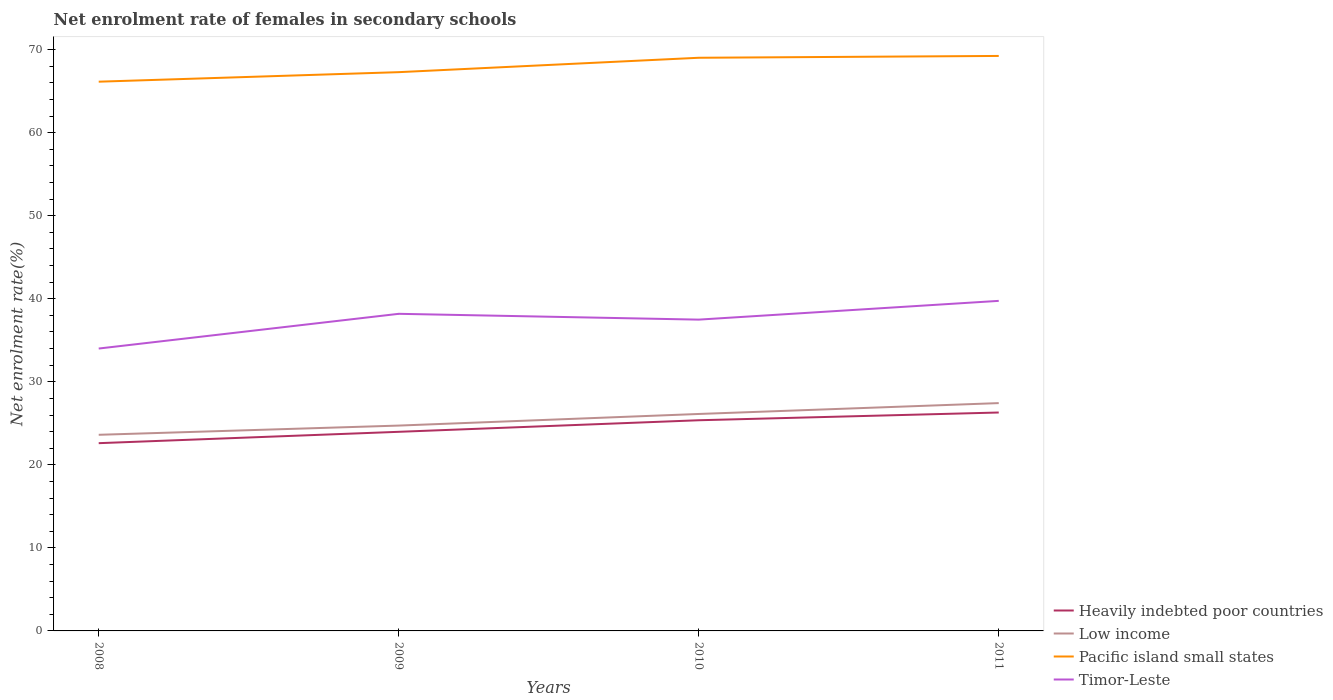Across all years, what is the maximum net enrolment rate of females in secondary schools in Timor-Leste?
Provide a short and direct response. 34.01. What is the total net enrolment rate of females in secondary schools in Heavily indebted poor countries in the graph?
Your answer should be very brief. -0.93. What is the difference between the highest and the second highest net enrolment rate of females in secondary schools in Low income?
Offer a very short reply. 3.82. What is the difference between the highest and the lowest net enrolment rate of females in secondary schools in Pacific island small states?
Your answer should be very brief. 2. Is the net enrolment rate of females in secondary schools in Heavily indebted poor countries strictly greater than the net enrolment rate of females in secondary schools in Pacific island small states over the years?
Your response must be concise. Yes. How many years are there in the graph?
Offer a terse response. 4. Are the values on the major ticks of Y-axis written in scientific E-notation?
Your response must be concise. No. Does the graph contain any zero values?
Give a very brief answer. No. Where does the legend appear in the graph?
Your answer should be compact. Bottom right. What is the title of the graph?
Give a very brief answer. Net enrolment rate of females in secondary schools. What is the label or title of the X-axis?
Your answer should be compact. Years. What is the label or title of the Y-axis?
Your answer should be compact. Net enrolment rate(%). What is the Net enrolment rate(%) of Heavily indebted poor countries in 2008?
Make the answer very short. 22.61. What is the Net enrolment rate(%) of Low income in 2008?
Keep it short and to the point. 23.62. What is the Net enrolment rate(%) in Pacific island small states in 2008?
Give a very brief answer. 66.15. What is the Net enrolment rate(%) in Timor-Leste in 2008?
Your answer should be very brief. 34.01. What is the Net enrolment rate(%) of Heavily indebted poor countries in 2009?
Ensure brevity in your answer.  23.98. What is the Net enrolment rate(%) in Low income in 2009?
Offer a very short reply. 24.73. What is the Net enrolment rate(%) of Pacific island small states in 2009?
Your response must be concise. 67.29. What is the Net enrolment rate(%) in Timor-Leste in 2009?
Give a very brief answer. 38.19. What is the Net enrolment rate(%) in Heavily indebted poor countries in 2010?
Make the answer very short. 25.37. What is the Net enrolment rate(%) of Low income in 2010?
Give a very brief answer. 26.13. What is the Net enrolment rate(%) in Pacific island small states in 2010?
Provide a short and direct response. 69.03. What is the Net enrolment rate(%) of Timor-Leste in 2010?
Offer a very short reply. 37.49. What is the Net enrolment rate(%) of Heavily indebted poor countries in 2011?
Ensure brevity in your answer.  26.3. What is the Net enrolment rate(%) of Low income in 2011?
Make the answer very short. 27.44. What is the Net enrolment rate(%) of Pacific island small states in 2011?
Make the answer very short. 69.25. What is the Net enrolment rate(%) in Timor-Leste in 2011?
Ensure brevity in your answer.  39.75. Across all years, what is the maximum Net enrolment rate(%) in Heavily indebted poor countries?
Your response must be concise. 26.3. Across all years, what is the maximum Net enrolment rate(%) in Low income?
Your answer should be compact. 27.44. Across all years, what is the maximum Net enrolment rate(%) in Pacific island small states?
Provide a short and direct response. 69.25. Across all years, what is the maximum Net enrolment rate(%) of Timor-Leste?
Ensure brevity in your answer.  39.75. Across all years, what is the minimum Net enrolment rate(%) of Heavily indebted poor countries?
Your answer should be very brief. 22.61. Across all years, what is the minimum Net enrolment rate(%) of Low income?
Provide a succinct answer. 23.62. Across all years, what is the minimum Net enrolment rate(%) of Pacific island small states?
Provide a short and direct response. 66.15. Across all years, what is the minimum Net enrolment rate(%) of Timor-Leste?
Ensure brevity in your answer.  34.01. What is the total Net enrolment rate(%) of Heavily indebted poor countries in the graph?
Keep it short and to the point. 98.27. What is the total Net enrolment rate(%) in Low income in the graph?
Ensure brevity in your answer.  101.92. What is the total Net enrolment rate(%) in Pacific island small states in the graph?
Keep it short and to the point. 271.71. What is the total Net enrolment rate(%) in Timor-Leste in the graph?
Ensure brevity in your answer.  149.44. What is the difference between the Net enrolment rate(%) in Heavily indebted poor countries in 2008 and that in 2009?
Your answer should be compact. -1.37. What is the difference between the Net enrolment rate(%) of Low income in 2008 and that in 2009?
Your answer should be compact. -1.11. What is the difference between the Net enrolment rate(%) in Pacific island small states in 2008 and that in 2009?
Make the answer very short. -1.15. What is the difference between the Net enrolment rate(%) in Timor-Leste in 2008 and that in 2009?
Offer a terse response. -4.18. What is the difference between the Net enrolment rate(%) in Heavily indebted poor countries in 2008 and that in 2010?
Keep it short and to the point. -2.76. What is the difference between the Net enrolment rate(%) of Low income in 2008 and that in 2010?
Ensure brevity in your answer.  -2.51. What is the difference between the Net enrolment rate(%) in Pacific island small states in 2008 and that in 2010?
Keep it short and to the point. -2.88. What is the difference between the Net enrolment rate(%) in Timor-Leste in 2008 and that in 2010?
Provide a succinct answer. -3.48. What is the difference between the Net enrolment rate(%) in Heavily indebted poor countries in 2008 and that in 2011?
Keep it short and to the point. -3.69. What is the difference between the Net enrolment rate(%) in Low income in 2008 and that in 2011?
Your response must be concise. -3.82. What is the difference between the Net enrolment rate(%) of Pacific island small states in 2008 and that in 2011?
Your response must be concise. -3.1. What is the difference between the Net enrolment rate(%) of Timor-Leste in 2008 and that in 2011?
Offer a terse response. -5.74. What is the difference between the Net enrolment rate(%) of Heavily indebted poor countries in 2009 and that in 2010?
Provide a succinct answer. -1.39. What is the difference between the Net enrolment rate(%) of Low income in 2009 and that in 2010?
Your answer should be compact. -1.4. What is the difference between the Net enrolment rate(%) in Pacific island small states in 2009 and that in 2010?
Your answer should be very brief. -1.73. What is the difference between the Net enrolment rate(%) in Timor-Leste in 2009 and that in 2010?
Give a very brief answer. 0.7. What is the difference between the Net enrolment rate(%) in Heavily indebted poor countries in 2009 and that in 2011?
Your answer should be compact. -2.33. What is the difference between the Net enrolment rate(%) in Low income in 2009 and that in 2011?
Keep it short and to the point. -2.71. What is the difference between the Net enrolment rate(%) in Pacific island small states in 2009 and that in 2011?
Provide a succinct answer. -1.95. What is the difference between the Net enrolment rate(%) in Timor-Leste in 2009 and that in 2011?
Provide a short and direct response. -1.56. What is the difference between the Net enrolment rate(%) of Heavily indebted poor countries in 2010 and that in 2011?
Your answer should be very brief. -0.93. What is the difference between the Net enrolment rate(%) in Low income in 2010 and that in 2011?
Your response must be concise. -1.31. What is the difference between the Net enrolment rate(%) in Pacific island small states in 2010 and that in 2011?
Give a very brief answer. -0.22. What is the difference between the Net enrolment rate(%) of Timor-Leste in 2010 and that in 2011?
Your answer should be compact. -2.26. What is the difference between the Net enrolment rate(%) in Heavily indebted poor countries in 2008 and the Net enrolment rate(%) in Low income in 2009?
Your answer should be compact. -2.12. What is the difference between the Net enrolment rate(%) in Heavily indebted poor countries in 2008 and the Net enrolment rate(%) in Pacific island small states in 2009?
Keep it short and to the point. -44.68. What is the difference between the Net enrolment rate(%) of Heavily indebted poor countries in 2008 and the Net enrolment rate(%) of Timor-Leste in 2009?
Ensure brevity in your answer.  -15.58. What is the difference between the Net enrolment rate(%) in Low income in 2008 and the Net enrolment rate(%) in Pacific island small states in 2009?
Make the answer very short. -43.67. What is the difference between the Net enrolment rate(%) in Low income in 2008 and the Net enrolment rate(%) in Timor-Leste in 2009?
Provide a short and direct response. -14.57. What is the difference between the Net enrolment rate(%) of Pacific island small states in 2008 and the Net enrolment rate(%) of Timor-Leste in 2009?
Offer a terse response. 27.96. What is the difference between the Net enrolment rate(%) of Heavily indebted poor countries in 2008 and the Net enrolment rate(%) of Low income in 2010?
Keep it short and to the point. -3.52. What is the difference between the Net enrolment rate(%) in Heavily indebted poor countries in 2008 and the Net enrolment rate(%) in Pacific island small states in 2010?
Your answer should be very brief. -46.42. What is the difference between the Net enrolment rate(%) in Heavily indebted poor countries in 2008 and the Net enrolment rate(%) in Timor-Leste in 2010?
Your response must be concise. -14.88. What is the difference between the Net enrolment rate(%) of Low income in 2008 and the Net enrolment rate(%) of Pacific island small states in 2010?
Offer a terse response. -45.41. What is the difference between the Net enrolment rate(%) of Low income in 2008 and the Net enrolment rate(%) of Timor-Leste in 2010?
Offer a terse response. -13.87. What is the difference between the Net enrolment rate(%) in Pacific island small states in 2008 and the Net enrolment rate(%) in Timor-Leste in 2010?
Your response must be concise. 28.66. What is the difference between the Net enrolment rate(%) in Heavily indebted poor countries in 2008 and the Net enrolment rate(%) in Low income in 2011?
Keep it short and to the point. -4.83. What is the difference between the Net enrolment rate(%) of Heavily indebted poor countries in 2008 and the Net enrolment rate(%) of Pacific island small states in 2011?
Keep it short and to the point. -46.64. What is the difference between the Net enrolment rate(%) of Heavily indebted poor countries in 2008 and the Net enrolment rate(%) of Timor-Leste in 2011?
Ensure brevity in your answer.  -17.14. What is the difference between the Net enrolment rate(%) of Low income in 2008 and the Net enrolment rate(%) of Pacific island small states in 2011?
Offer a very short reply. -45.63. What is the difference between the Net enrolment rate(%) of Low income in 2008 and the Net enrolment rate(%) of Timor-Leste in 2011?
Your response must be concise. -16.13. What is the difference between the Net enrolment rate(%) of Pacific island small states in 2008 and the Net enrolment rate(%) of Timor-Leste in 2011?
Offer a terse response. 26.4. What is the difference between the Net enrolment rate(%) in Heavily indebted poor countries in 2009 and the Net enrolment rate(%) in Low income in 2010?
Provide a short and direct response. -2.15. What is the difference between the Net enrolment rate(%) of Heavily indebted poor countries in 2009 and the Net enrolment rate(%) of Pacific island small states in 2010?
Provide a short and direct response. -45.05. What is the difference between the Net enrolment rate(%) of Heavily indebted poor countries in 2009 and the Net enrolment rate(%) of Timor-Leste in 2010?
Provide a succinct answer. -13.51. What is the difference between the Net enrolment rate(%) in Low income in 2009 and the Net enrolment rate(%) in Pacific island small states in 2010?
Keep it short and to the point. -44.3. What is the difference between the Net enrolment rate(%) in Low income in 2009 and the Net enrolment rate(%) in Timor-Leste in 2010?
Provide a short and direct response. -12.76. What is the difference between the Net enrolment rate(%) in Pacific island small states in 2009 and the Net enrolment rate(%) in Timor-Leste in 2010?
Ensure brevity in your answer.  29.8. What is the difference between the Net enrolment rate(%) of Heavily indebted poor countries in 2009 and the Net enrolment rate(%) of Low income in 2011?
Provide a succinct answer. -3.46. What is the difference between the Net enrolment rate(%) of Heavily indebted poor countries in 2009 and the Net enrolment rate(%) of Pacific island small states in 2011?
Give a very brief answer. -45.27. What is the difference between the Net enrolment rate(%) of Heavily indebted poor countries in 2009 and the Net enrolment rate(%) of Timor-Leste in 2011?
Make the answer very short. -15.77. What is the difference between the Net enrolment rate(%) of Low income in 2009 and the Net enrolment rate(%) of Pacific island small states in 2011?
Make the answer very short. -44.52. What is the difference between the Net enrolment rate(%) of Low income in 2009 and the Net enrolment rate(%) of Timor-Leste in 2011?
Your answer should be compact. -15.02. What is the difference between the Net enrolment rate(%) of Pacific island small states in 2009 and the Net enrolment rate(%) of Timor-Leste in 2011?
Ensure brevity in your answer.  27.54. What is the difference between the Net enrolment rate(%) in Heavily indebted poor countries in 2010 and the Net enrolment rate(%) in Low income in 2011?
Offer a very short reply. -2.06. What is the difference between the Net enrolment rate(%) in Heavily indebted poor countries in 2010 and the Net enrolment rate(%) in Pacific island small states in 2011?
Provide a short and direct response. -43.87. What is the difference between the Net enrolment rate(%) of Heavily indebted poor countries in 2010 and the Net enrolment rate(%) of Timor-Leste in 2011?
Ensure brevity in your answer.  -14.38. What is the difference between the Net enrolment rate(%) in Low income in 2010 and the Net enrolment rate(%) in Pacific island small states in 2011?
Your answer should be compact. -43.12. What is the difference between the Net enrolment rate(%) of Low income in 2010 and the Net enrolment rate(%) of Timor-Leste in 2011?
Make the answer very short. -13.62. What is the difference between the Net enrolment rate(%) of Pacific island small states in 2010 and the Net enrolment rate(%) of Timor-Leste in 2011?
Offer a terse response. 29.28. What is the average Net enrolment rate(%) in Heavily indebted poor countries per year?
Offer a very short reply. 24.57. What is the average Net enrolment rate(%) of Low income per year?
Offer a very short reply. 25.48. What is the average Net enrolment rate(%) in Pacific island small states per year?
Your response must be concise. 67.93. What is the average Net enrolment rate(%) of Timor-Leste per year?
Ensure brevity in your answer.  37.36. In the year 2008, what is the difference between the Net enrolment rate(%) of Heavily indebted poor countries and Net enrolment rate(%) of Low income?
Give a very brief answer. -1.01. In the year 2008, what is the difference between the Net enrolment rate(%) in Heavily indebted poor countries and Net enrolment rate(%) in Pacific island small states?
Give a very brief answer. -43.53. In the year 2008, what is the difference between the Net enrolment rate(%) in Heavily indebted poor countries and Net enrolment rate(%) in Timor-Leste?
Ensure brevity in your answer.  -11.4. In the year 2008, what is the difference between the Net enrolment rate(%) of Low income and Net enrolment rate(%) of Pacific island small states?
Your response must be concise. -42.53. In the year 2008, what is the difference between the Net enrolment rate(%) of Low income and Net enrolment rate(%) of Timor-Leste?
Make the answer very short. -10.39. In the year 2008, what is the difference between the Net enrolment rate(%) of Pacific island small states and Net enrolment rate(%) of Timor-Leste?
Make the answer very short. 32.14. In the year 2009, what is the difference between the Net enrolment rate(%) in Heavily indebted poor countries and Net enrolment rate(%) in Low income?
Keep it short and to the point. -0.75. In the year 2009, what is the difference between the Net enrolment rate(%) in Heavily indebted poor countries and Net enrolment rate(%) in Pacific island small states?
Offer a terse response. -43.31. In the year 2009, what is the difference between the Net enrolment rate(%) in Heavily indebted poor countries and Net enrolment rate(%) in Timor-Leste?
Keep it short and to the point. -14.21. In the year 2009, what is the difference between the Net enrolment rate(%) of Low income and Net enrolment rate(%) of Pacific island small states?
Provide a short and direct response. -42.56. In the year 2009, what is the difference between the Net enrolment rate(%) of Low income and Net enrolment rate(%) of Timor-Leste?
Provide a short and direct response. -13.46. In the year 2009, what is the difference between the Net enrolment rate(%) in Pacific island small states and Net enrolment rate(%) in Timor-Leste?
Ensure brevity in your answer.  29.1. In the year 2010, what is the difference between the Net enrolment rate(%) in Heavily indebted poor countries and Net enrolment rate(%) in Low income?
Your response must be concise. -0.76. In the year 2010, what is the difference between the Net enrolment rate(%) of Heavily indebted poor countries and Net enrolment rate(%) of Pacific island small states?
Your answer should be compact. -43.66. In the year 2010, what is the difference between the Net enrolment rate(%) in Heavily indebted poor countries and Net enrolment rate(%) in Timor-Leste?
Your answer should be compact. -12.12. In the year 2010, what is the difference between the Net enrolment rate(%) in Low income and Net enrolment rate(%) in Pacific island small states?
Your answer should be compact. -42.9. In the year 2010, what is the difference between the Net enrolment rate(%) in Low income and Net enrolment rate(%) in Timor-Leste?
Offer a very short reply. -11.36. In the year 2010, what is the difference between the Net enrolment rate(%) of Pacific island small states and Net enrolment rate(%) of Timor-Leste?
Give a very brief answer. 31.54. In the year 2011, what is the difference between the Net enrolment rate(%) in Heavily indebted poor countries and Net enrolment rate(%) in Low income?
Make the answer very short. -1.13. In the year 2011, what is the difference between the Net enrolment rate(%) in Heavily indebted poor countries and Net enrolment rate(%) in Pacific island small states?
Make the answer very short. -42.94. In the year 2011, what is the difference between the Net enrolment rate(%) in Heavily indebted poor countries and Net enrolment rate(%) in Timor-Leste?
Give a very brief answer. -13.45. In the year 2011, what is the difference between the Net enrolment rate(%) of Low income and Net enrolment rate(%) of Pacific island small states?
Provide a short and direct response. -41.81. In the year 2011, what is the difference between the Net enrolment rate(%) in Low income and Net enrolment rate(%) in Timor-Leste?
Your answer should be very brief. -12.31. In the year 2011, what is the difference between the Net enrolment rate(%) in Pacific island small states and Net enrolment rate(%) in Timor-Leste?
Ensure brevity in your answer.  29.5. What is the ratio of the Net enrolment rate(%) of Heavily indebted poor countries in 2008 to that in 2009?
Offer a very short reply. 0.94. What is the ratio of the Net enrolment rate(%) in Low income in 2008 to that in 2009?
Keep it short and to the point. 0.96. What is the ratio of the Net enrolment rate(%) of Pacific island small states in 2008 to that in 2009?
Keep it short and to the point. 0.98. What is the ratio of the Net enrolment rate(%) in Timor-Leste in 2008 to that in 2009?
Your answer should be compact. 0.89. What is the ratio of the Net enrolment rate(%) in Heavily indebted poor countries in 2008 to that in 2010?
Make the answer very short. 0.89. What is the ratio of the Net enrolment rate(%) of Low income in 2008 to that in 2010?
Offer a very short reply. 0.9. What is the ratio of the Net enrolment rate(%) of Pacific island small states in 2008 to that in 2010?
Ensure brevity in your answer.  0.96. What is the ratio of the Net enrolment rate(%) of Timor-Leste in 2008 to that in 2010?
Your response must be concise. 0.91. What is the ratio of the Net enrolment rate(%) of Heavily indebted poor countries in 2008 to that in 2011?
Your response must be concise. 0.86. What is the ratio of the Net enrolment rate(%) in Low income in 2008 to that in 2011?
Your response must be concise. 0.86. What is the ratio of the Net enrolment rate(%) in Pacific island small states in 2008 to that in 2011?
Your response must be concise. 0.96. What is the ratio of the Net enrolment rate(%) in Timor-Leste in 2008 to that in 2011?
Make the answer very short. 0.86. What is the ratio of the Net enrolment rate(%) in Heavily indebted poor countries in 2009 to that in 2010?
Offer a very short reply. 0.95. What is the ratio of the Net enrolment rate(%) in Low income in 2009 to that in 2010?
Your response must be concise. 0.95. What is the ratio of the Net enrolment rate(%) of Pacific island small states in 2009 to that in 2010?
Your answer should be compact. 0.97. What is the ratio of the Net enrolment rate(%) in Timor-Leste in 2009 to that in 2010?
Give a very brief answer. 1.02. What is the ratio of the Net enrolment rate(%) in Heavily indebted poor countries in 2009 to that in 2011?
Make the answer very short. 0.91. What is the ratio of the Net enrolment rate(%) of Low income in 2009 to that in 2011?
Provide a succinct answer. 0.9. What is the ratio of the Net enrolment rate(%) in Pacific island small states in 2009 to that in 2011?
Provide a short and direct response. 0.97. What is the ratio of the Net enrolment rate(%) of Timor-Leste in 2009 to that in 2011?
Provide a succinct answer. 0.96. What is the ratio of the Net enrolment rate(%) in Heavily indebted poor countries in 2010 to that in 2011?
Keep it short and to the point. 0.96. What is the ratio of the Net enrolment rate(%) in Low income in 2010 to that in 2011?
Offer a very short reply. 0.95. What is the ratio of the Net enrolment rate(%) of Timor-Leste in 2010 to that in 2011?
Offer a terse response. 0.94. What is the difference between the highest and the second highest Net enrolment rate(%) of Heavily indebted poor countries?
Provide a succinct answer. 0.93. What is the difference between the highest and the second highest Net enrolment rate(%) of Low income?
Your response must be concise. 1.31. What is the difference between the highest and the second highest Net enrolment rate(%) of Pacific island small states?
Make the answer very short. 0.22. What is the difference between the highest and the second highest Net enrolment rate(%) in Timor-Leste?
Make the answer very short. 1.56. What is the difference between the highest and the lowest Net enrolment rate(%) in Heavily indebted poor countries?
Ensure brevity in your answer.  3.69. What is the difference between the highest and the lowest Net enrolment rate(%) in Low income?
Give a very brief answer. 3.82. What is the difference between the highest and the lowest Net enrolment rate(%) in Pacific island small states?
Your response must be concise. 3.1. What is the difference between the highest and the lowest Net enrolment rate(%) of Timor-Leste?
Your response must be concise. 5.74. 